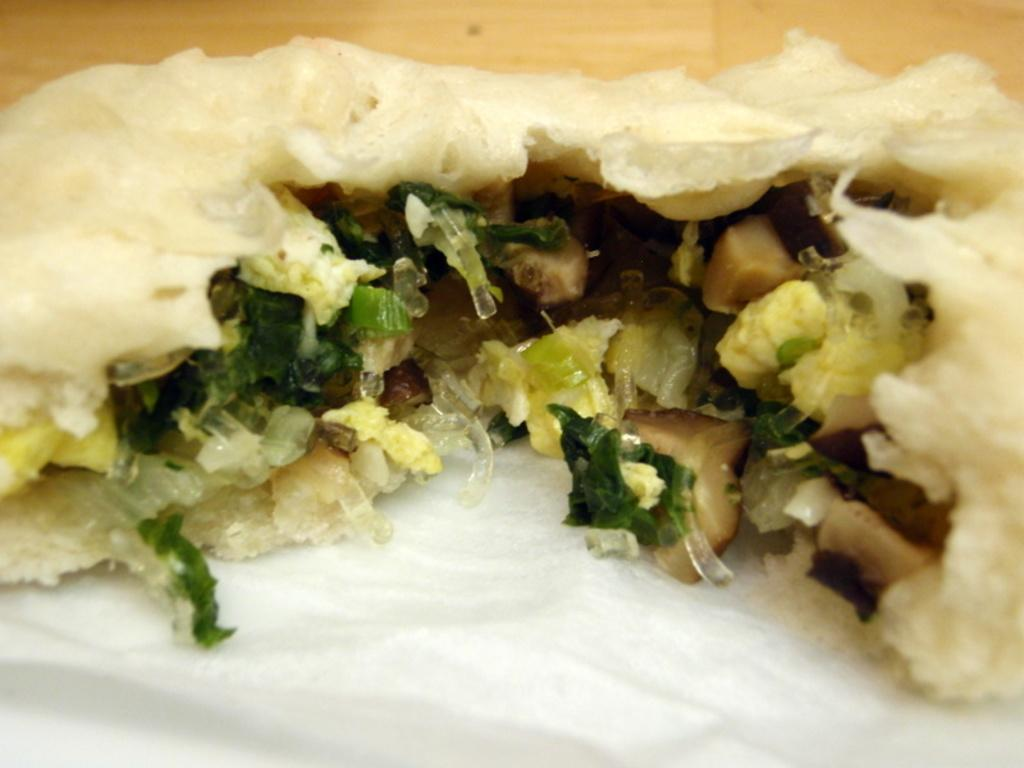What types of items can be seen in the image? There are food items in the image. On what surface are the food items placed? The food items are placed on a white surface. What can be seen in the background of the image? There is a wooden surface visible in the background of the image. What type of guitar is being played in the scene depicted in the image? There is no guitar or scene present in the image; it only features food items on a white surface with a wooden background. 